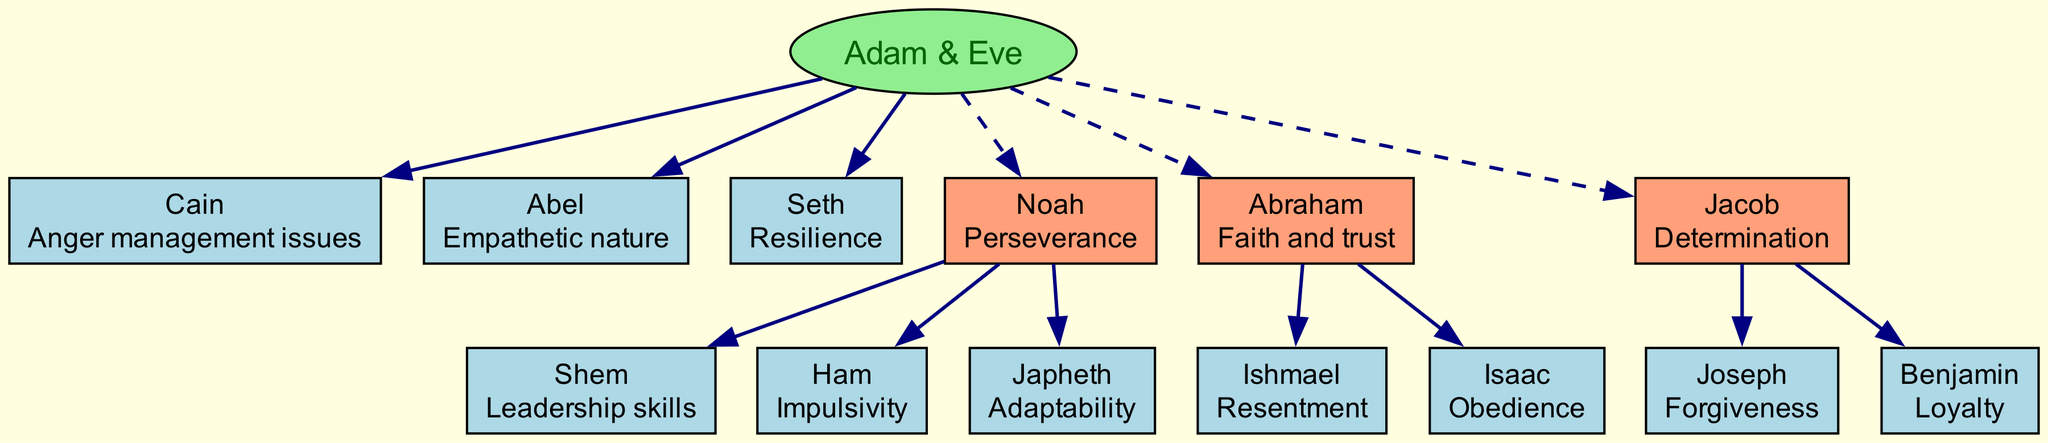What are the psychological traits of Cain? The diagram indicates that Cain has "Anger management issues" as his psychological trait. This information is directly labeled on the node associated with Cain.
Answer: Anger management issues How many children did Noah have? By examining the diagram, we can see that Noah has three children listed: Shem, Ham, and Japheth. Therefore, the total number of children is three.
Answer: 3 What is the relationship between Jacob and Joseph? The diagram shows that Joseph is a child of Jacob, indicating a parent-child relationship between the two figures.
Answer: Parent-child Which Biblical figure is associated with resilience? The diagram labels Seth with "Resilience" as his psychological trait. By locating Seth, we can directly answer this question.
Answer: Seth Who is described as having leadership skills? The diagram lists Shem under Noah, and his psychological trait is indicated as "Leadership skills." Thus, the answer is based on the information provided for Shem.
Answer: Shem What is the trait noted for Abraham? According to the diagram, Abraham is associated with the trait "Faith and trust." This trait is explicitly mentioned alongside his name.
Answer: Faith and trust Which descendant of Noah is known for impulsivity? The diagram describes Ham, one of Noah's children, with the trait "Impulsivity." By identifying Ham's position in the family tree, we can provide the answer.
Answer: Ham How many total descendants are listed for Adam and Eve in the diagram? Counting all children under Adam and Eve, which includes Cain, Abel, Seth, Noah, Abraham, and Jacob, we determine there are six total descendants. This includes both immediate children and generational descendants.
Answer: 6 What psychological trait is associated with Benjamin? The diagram specifies that Benjamin has the trait of "Loyalty." This can be found directly next to Benjamin’s name in the diagram.
Answer: Loyalty 